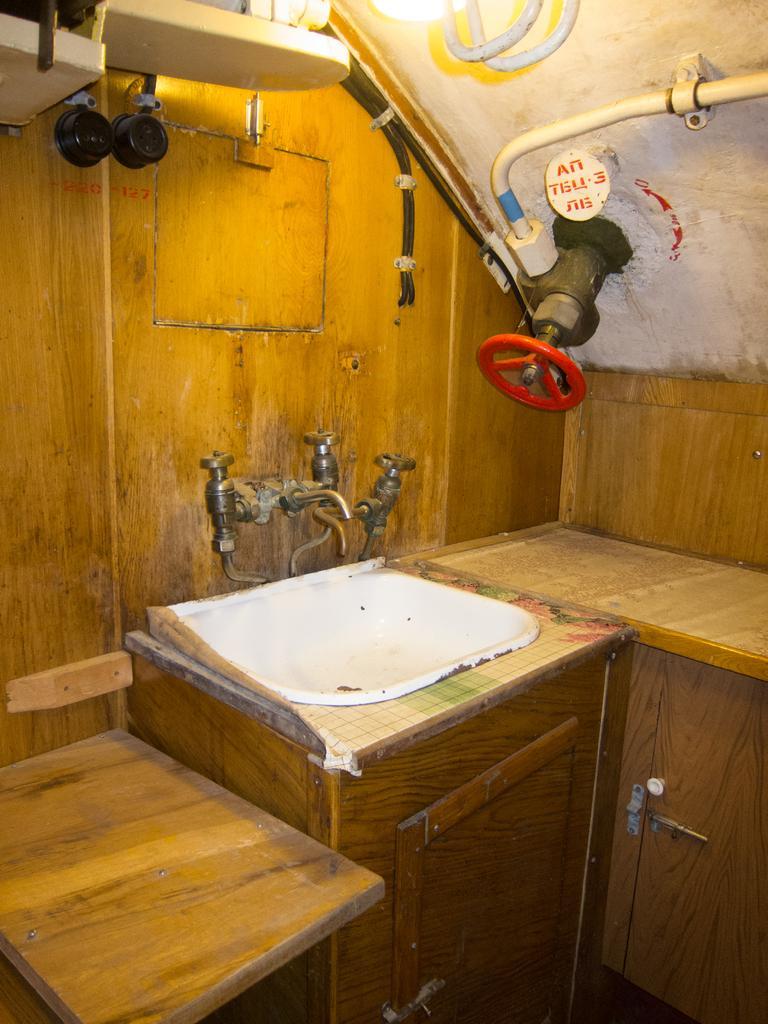In one or two sentences, can you explain what this image depicts? In the foreground of this image, there is a sink, few wooden cupboards, wooden slab, a circular regulator like an object on the wall, few pipes, a light at the top and two black color objects on the wall on the left. 